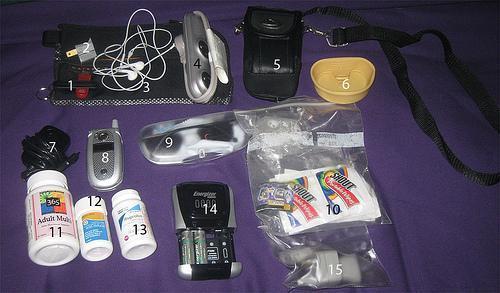How many batteries are in the charger?
Give a very brief answer. 2. How many items are numbered?
Give a very brief answer. 15. 